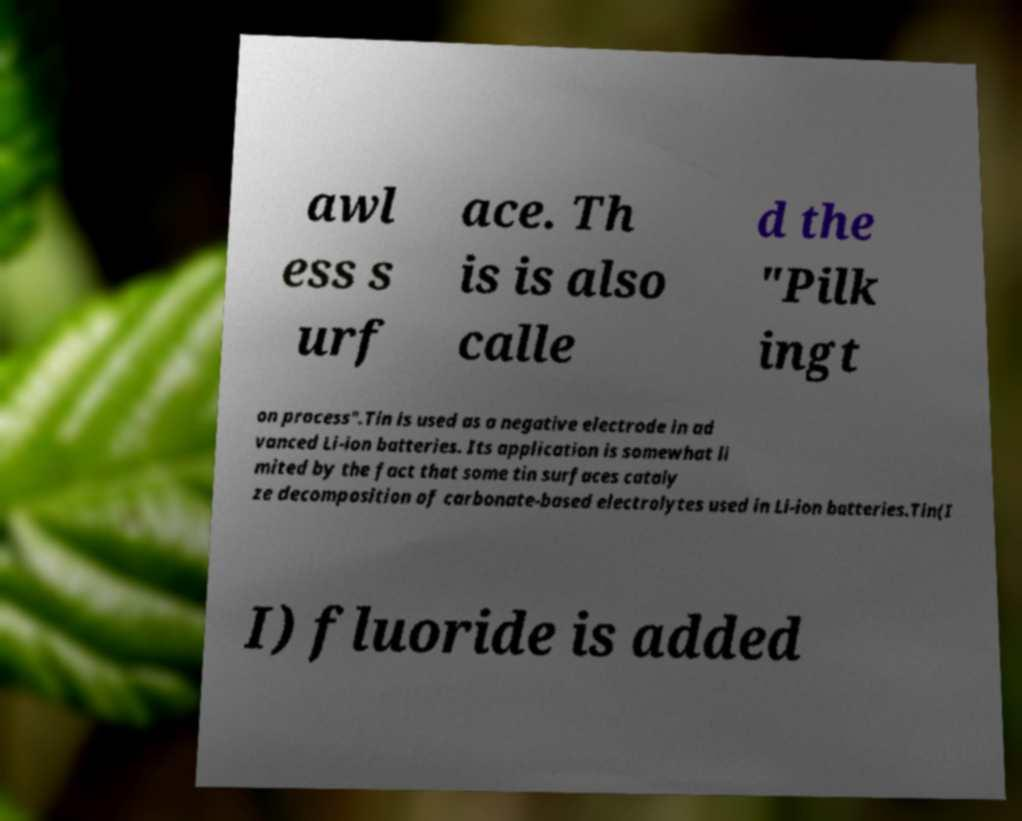Could you extract and type out the text from this image? awl ess s urf ace. Th is is also calle d the "Pilk ingt on process".Tin is used as a negative electrode in ad vanced Li-ion batteries. Its application is somewhat li mited by the fact that some tin surfaces cataly ze decomposition of carbonate-based electrolytes used in Li-ion batteries.Tin(I I) fluoride is added 